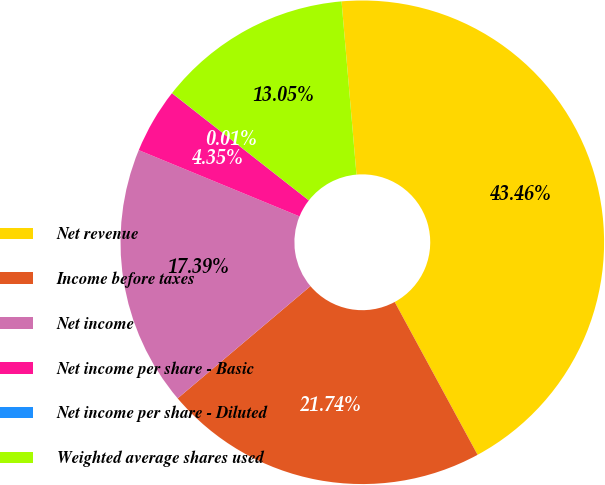<chart> <loc_0><loc_0><loc_500><loc_500><pie_chart><fcel>Net revenue<fcel>Income before taxes<fcel>Net income<fcel>Net income per share - Basic<fcel>Net income per share - Diluted<fcel>Weighted average shares used<nl><fcel>43.46%<fcel>21.74%<fcel>17.39%<fcel>4.35%<fcel>0.01%<fcel>13.05%<nl></chart> 